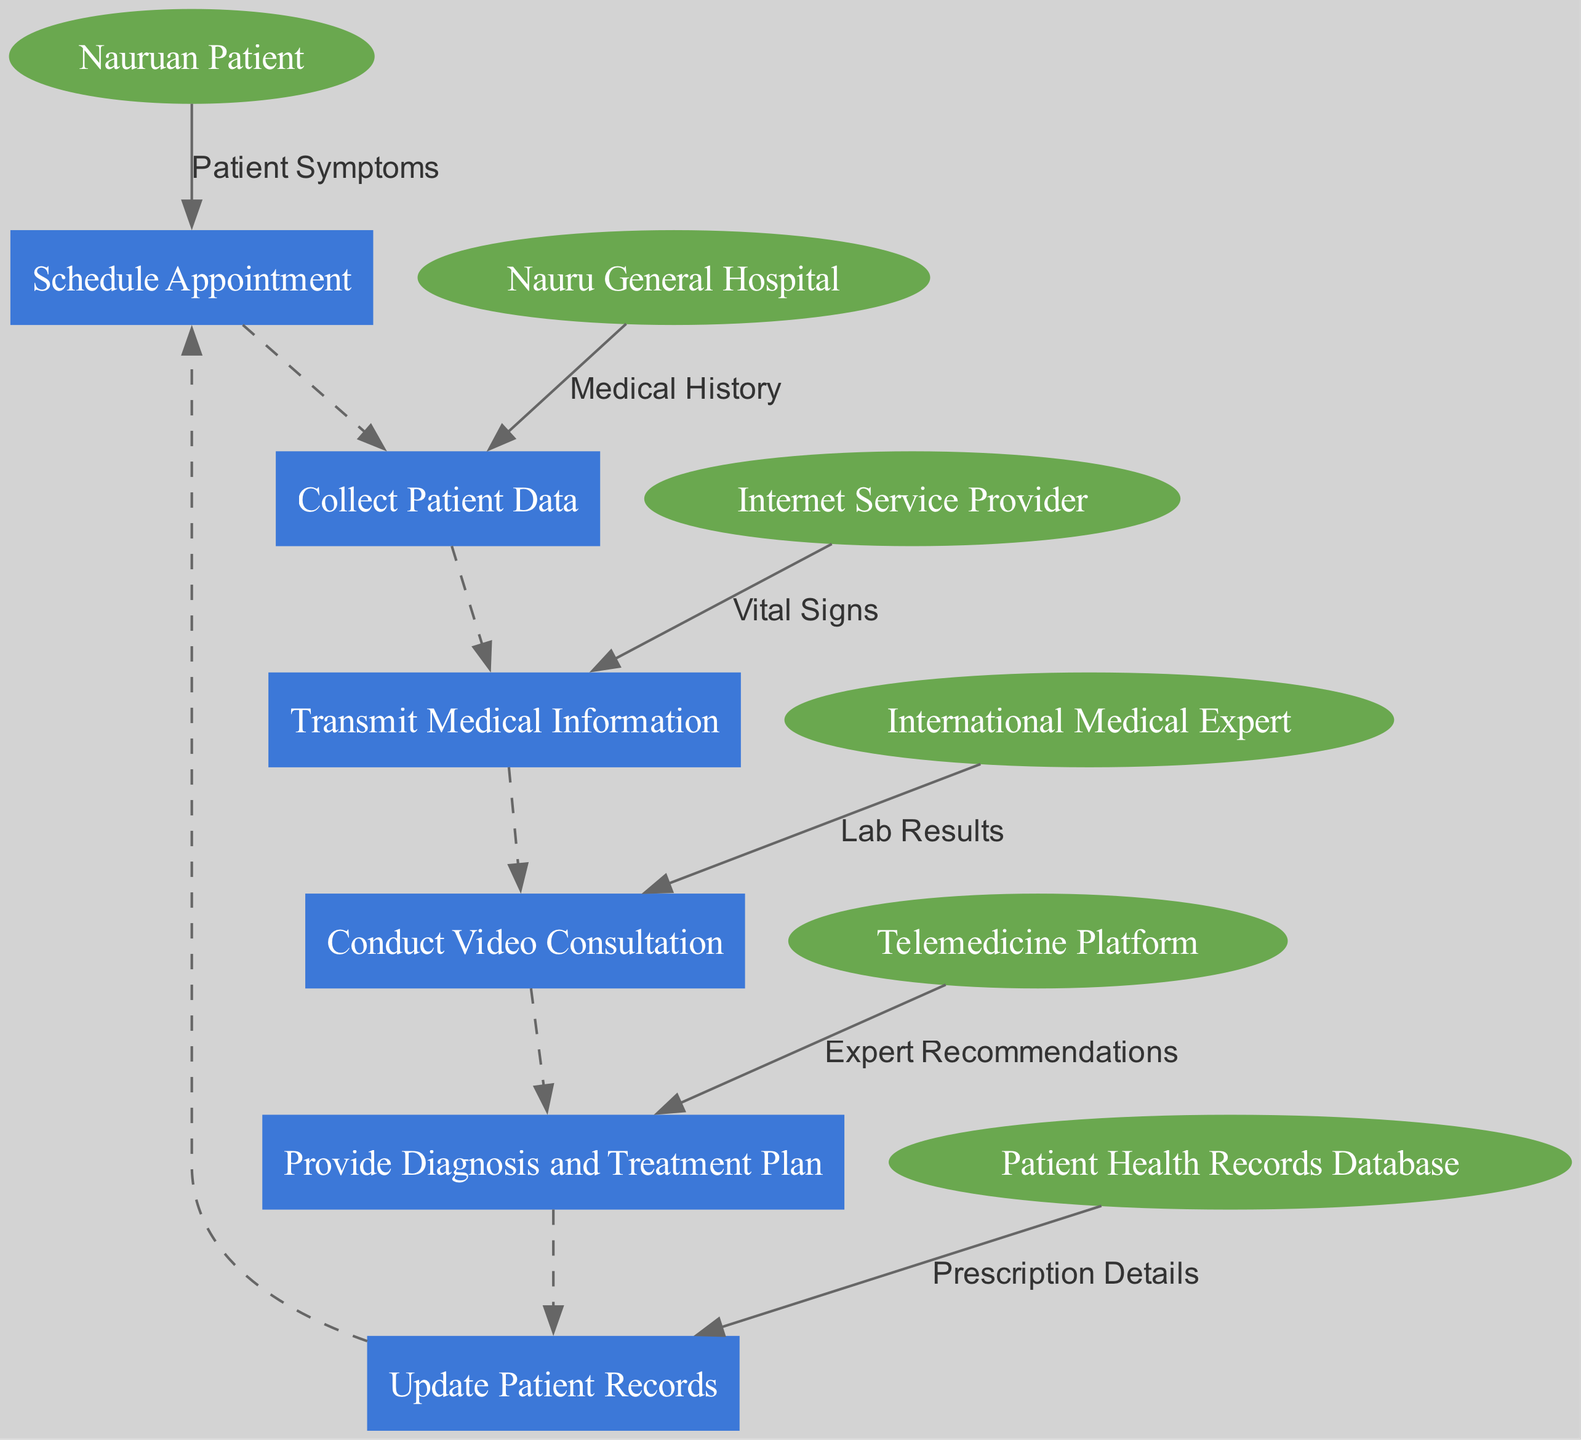What is the starting point of the telemedicine process? The telemedicine process begins with the "Nauruan Patient," who initiates the consultation. This is visually represented as the first entity in the diagram.
Answer: Nauruan Patient How many entities are represented in the diagram? The diagram includes six distinct entities: Nauruan Patient, Nauru General Hospital, Internet Service Provider, International Medical Expert, Telemedicine Platform, and Patient Health Records Database. This can be counted directly from the list of entities.
Answer: 6 Which process follows "Collect Patient Data"? The process immediately following "Collect Patient Data" is "Transmit Medical Information," as illustrated by the sequential flow of processes in the diagram, showing their order.
Answer: Transmit Medical Information What type of information is transmitted from the Nauruan Patient to the Telemedicine Platform? The information transmitted from the Nauruan Patient to the Telemedicine Platform includes "Patient Symptoms," as indicated by the directed edge in the data flow diagram showing patient data collection.
Answer: Patient Symptoms How many data flows are represented in the diagram? The diagram shows six data flows, which can be counted from the directed edges connecting entities and processes, detailing the specific pieces of information shared throughout the telemedicine process.
Answer: 6 Which entity receives "Expert Recommendations"? The "International Medical Expert" receives "Expert Recommendations" after the video consultation, as shown in the flow of information from the process to the entity in the diagram.
Answer: International Medical Expert What happens after "Conduct Video Consultation"? Following "Conduct Video Consultation," the next process is "Provide Diagnosis and Treatment Plan," as this follows the structured sequence of processes in the diagram.
Answer: Provide Diagnosis and Treatment Plan What is the role of the Internet Service Provider in this process? The Internet Service Provider facilitates the connectivity needed for telemedicine consultations between the Nauruan Patient and the International Medical Expert, which highlights its role as a vital service provider.
Answer: Connectivity What information is updated after "Provide Diagnosis and Treatment Plan"? After providing a diagnosis and treatment plan, "Update Patient Records" is conducted to ensure that the patient's health record is current with new information, as indicated by the process flow.
Answer: Update Patient Records 